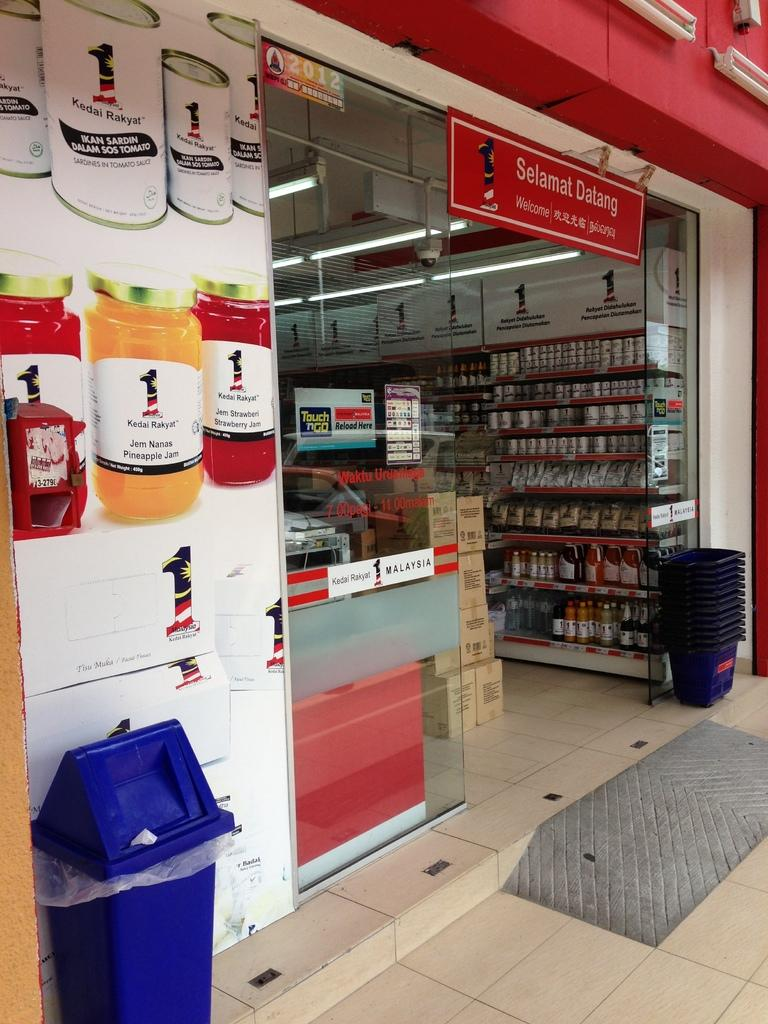Provide a one-sentence caption for the provided image. a yellow jar with Kedai written on it. 